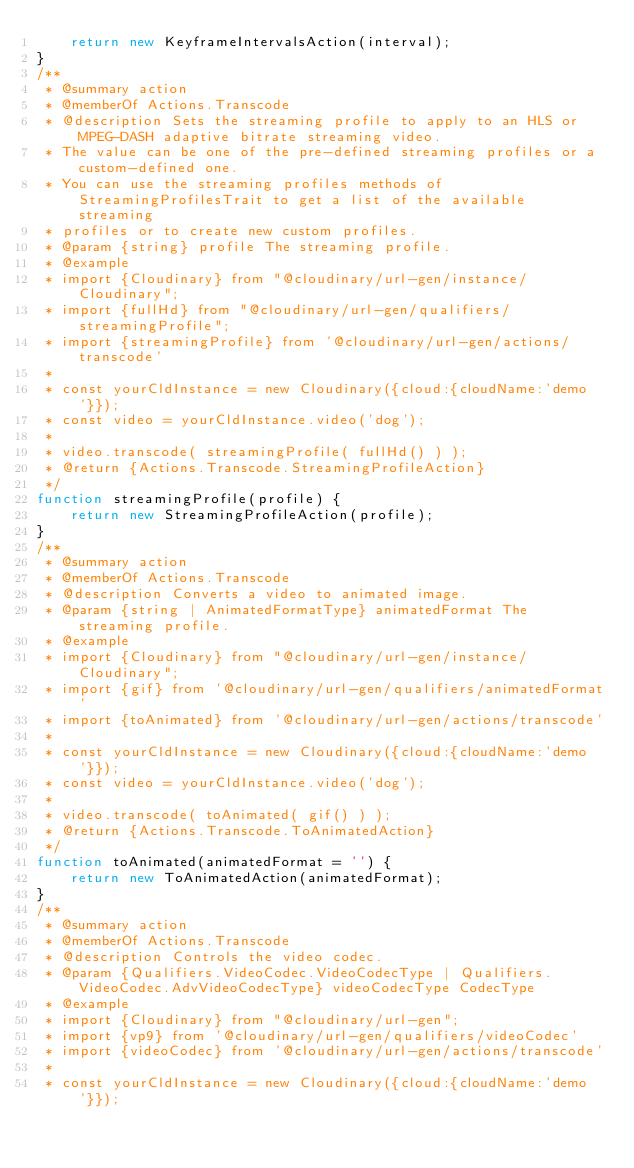<code> <loc_0><loc_0><loc_500><loc_500><_JavaScript_>    return new KeyframeIntervalsAction(interval);
}
/**
 * @summary action
 * @memberOf Actions.Transcode
 * @description Sets the streaming profile to apply to an HLS or MPEG-DASH adaptive bitrate streaming video.
 * The value can be one of the pre-defined streaming profiles or a custom-defined one.
 * You can use the streaming profiles methods of StreamingProfilesTrait to get a list of the available streaming
 * profiles or to create new custom profiles.
 * @param {string} profile The streaming profile.
 * @example
 * import {Cloudinary} from "@cloudinary/url-gen/instance/Cloudinary";
 * import {fullHd} from "@cloudinary/url-gen/qualifiers/streamingProfile";
 * import {streamingProfile} from '@cloudinary/url-gen/actions/transcode'
 *
 * const yourCldInstance = new Cloudinary({cloud:{cloudName:'demo'}});
 * const video = yourCldInstance.video('dog');
 *
 * video.transcode( streamingProfile( fullHd() ) );
 * @return {Actions.Transcode.StreamingProfileAction}
 */
function streamingProfile(profile) {
    return new StreamingProfileAction(profile);
}
/**
 * @summary action
 * @memberOf Actions.Transcode
 * @description Converts a video to animated image.
 * @param {string | AnimatedFormatType} animatedFormat The streaming profile.
 * @example
 * import {Cloudinary} from "@cloudinary/url-gen/instance/Cloudinary";
 * import {gif} from '@cloudinary/url-gen/qualifiers/animatedFormat'
 * import {toAnimated} from '@cloudinary/url-gen/actions/transcode'
 *
 * const yourCldInstance = new Cloudinary({cloud:{cloudName:'demo'}});
 * const video = yourCldInstance.video('dog');
 *
 * video.transcode( toAnimated( gif() ) );
 * @return {Actions.Transcode.ToAnimatedAction}
 */
function toAnimated(animatedFormat = '') {
    return new ToAnimatedAction(animatedFormat);
}
/**
 * @summary action
 * @memberOf Actions.Transcode
 * @description Controls the video codec.
 * @param {Qualifiers.VideoCodec.VideoCodecType | Qualifiers.VideoCodec.AdvVideoCodecType} videoCodecType CodecType
 * @example
 * import {Cloudinary} from "@cloudinary/url-gen";
 * import {vp9} from '@cloudinary/url-gen/qualifiers/videoCodec'
 * import {videoCodec} from '@cloudinary/url-gen/actions/transcode'
 *
 * const yourCldInstance = new Cloudinary({cloud:{cloudName:'demo'}});</code> 